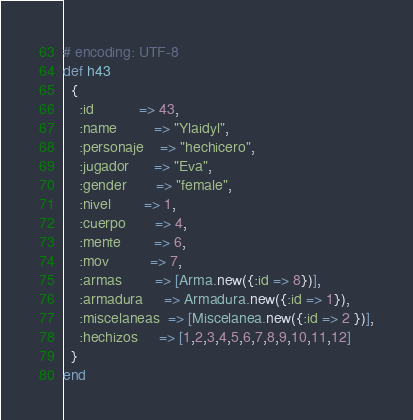<code> <loc_0><loc_0><loc_500><loc_500><_Ruby_># encoding: UTF-8
def h43
  { 
    :id           => 43,
    :name         => "Ylaidyl",
    :personaje    => "hechicero",
    :jugador      => "Eva",
    :gender       => "female",
    :nivel        => 1,
    :cuerpo       => 4,
    :mente        => 6,
    :mov          => 7,
    :armas        => [Arma.new({:id => 8})],
    :armadura     => Armadura.new({:id => 1}),
    :miscelaneas  => [Miscelanea.new({:id => 2 })],
    :hechizos     => [1,2,3,4,5,6,7,8,9,10,11,12]
  }
end</code> 